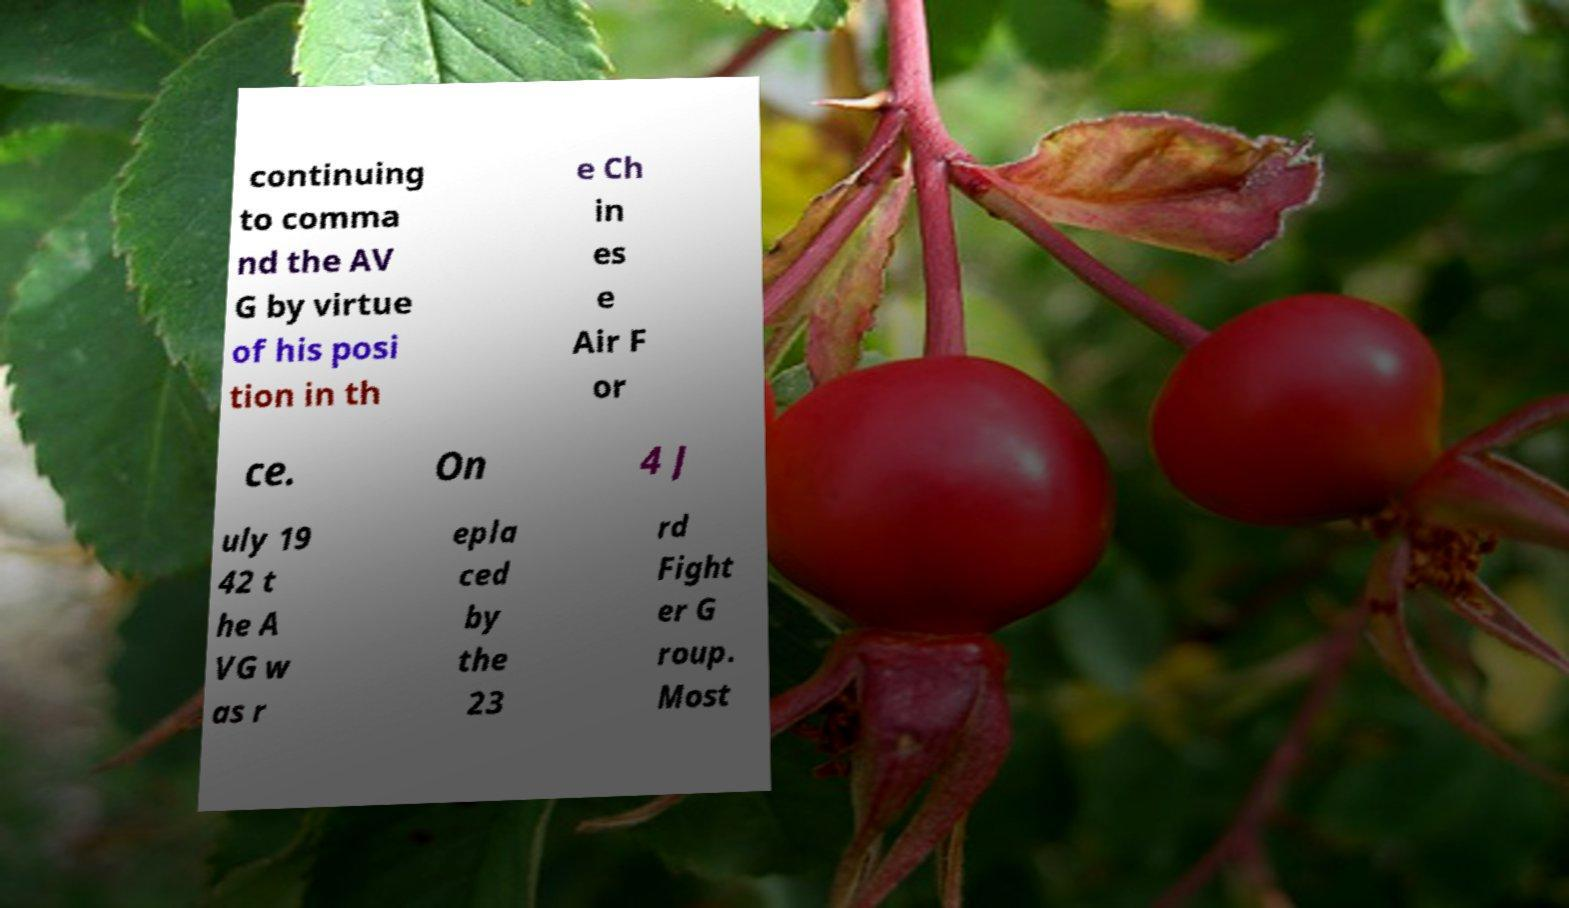There's text embedded in this image that I need extracted. Can you transcribe it verbatim? continuing to comma nd the AV G by virtue of his posi tion in th e Ch in es e Air F or ce. On 4 J uly 19 42 t he A VG w as r epla ced by the 23 rd Fight er G roup. Most 